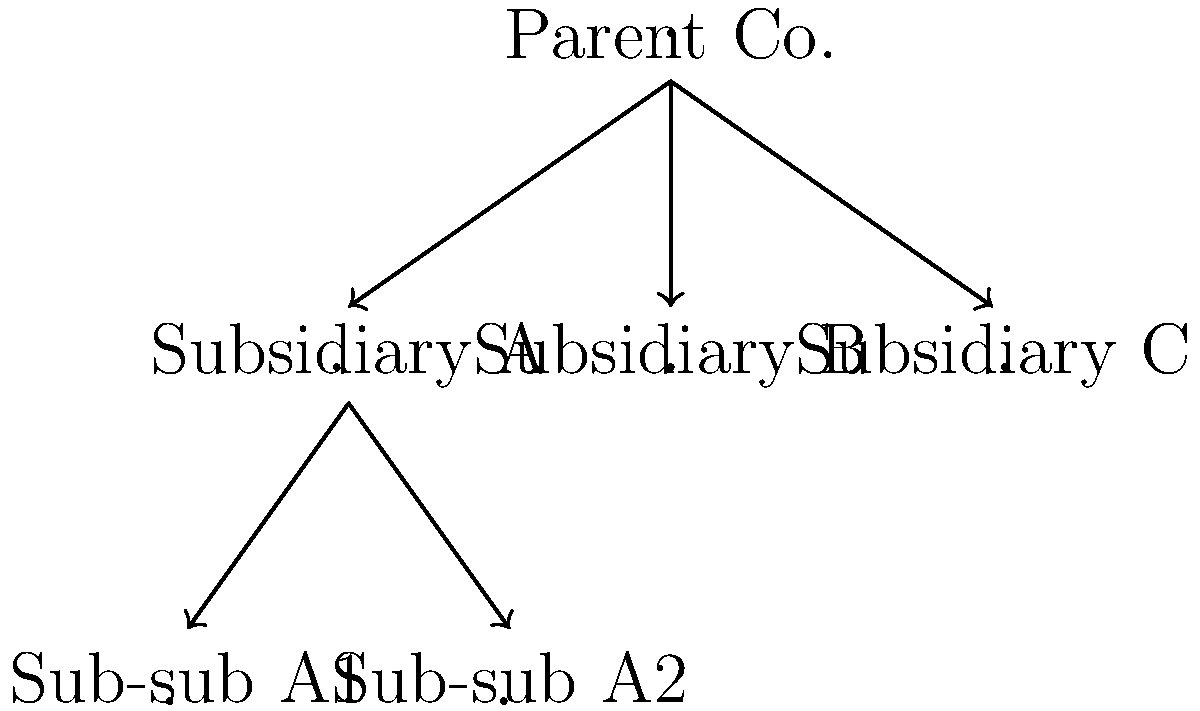Analyze the corporate structure depicted in the network diagram. If Subsidiary A is found liable for environmental damages, under what circumstances might the Parent Company be held responsible, and how does this network structure potentially affect the extent of liability? Discuss the legal principle of "piercing the corporate veil" in your answer. To answer this question, we need to consider several key points:

1. Corporate Separateness: Generally, corporations are treated as separate legal entities from their shareholders, including parent companies. This principle typically shields parent companies from liability for their subsidiaries' actions.

2. Piercing the Corporate Veil: This legal doctrine allows courts to disregard the corporate entity and hold shareholders (including parent companies) responsible for the corporation's actions. To "pierce the veil," courts typically look for:

   a) Inadequate capitalization
   b) Failure to observe corporate formalities
   c) Commingling of funds and assets
   d) Use of the corporate form for fraudulent purposes

3. Control and Domination: The degree of control exercised by the parent over the subsidiary is crucial. If the parent exerts excessive control, it may be seen as the subsidiary's "alter ego."

4. Environmental Law Considerations: Environmental laws often have specific provisions for parent company liability, which may be stricter than general corporate law principles.

5. Network Structure Impact: The multi-tiered structure (Parent Co. -> Subsidiary A -> Sub-sub A1 and A2) could potentially insulate the Parent Company further, as there are more layers of separation between it and the liable entity.

To determine if the Parent Company might be held responsible:

1. Examine the relationship between Parent Co. and Subsidiary A:
   - Does Parent Co. maintain proper corporate separateness?
   - Is there evidence of excessive control or domination?

2. Investigate Subsidiary A's corporate practices:
   - Is it adequately capitalized?
   - Does it observe proper corporate formalities?
   - Are its funds and assets kept separate from the Parent Co.?

3. Consider the nature of the environmental damage:
   - Are there specific environmental laws that extend liability to parent companies?
   - Was there any direct involvement of Parent Co. in the actions leading to the damage?

4. Analyze the impact of the network structure:
   - Does the presence of Sub-sub A1 and A2 further insulate Parent Co., or does it suggest a pattern of corporate structuring to avoid liability?

The extent of liability could be affected by this network structure in several ways:

1. Limited Liability: If corporate separateness is maintained, liability might be confined to Subsidiary A and its assets.
2. Partial Piercing: Courts might pierce the veil to reach Subsidiary A's assets but not those of Parent Co.
3. Full Piercing: In cases of egregious misconduct or fraud, courts might pierce through all layers to hold Parent Co. liable.

The key is to demonstrate that, despite the network structure, there are compelling reasons to disregard the corporate form and hold the Parent Company responsible.
Answer: Parent Company may be held liable if corporate veil is pierced due to inadequate separateness, excessive control, or fraudulent structuring, despite the multi-tiered network potentially providing additional insulation. 